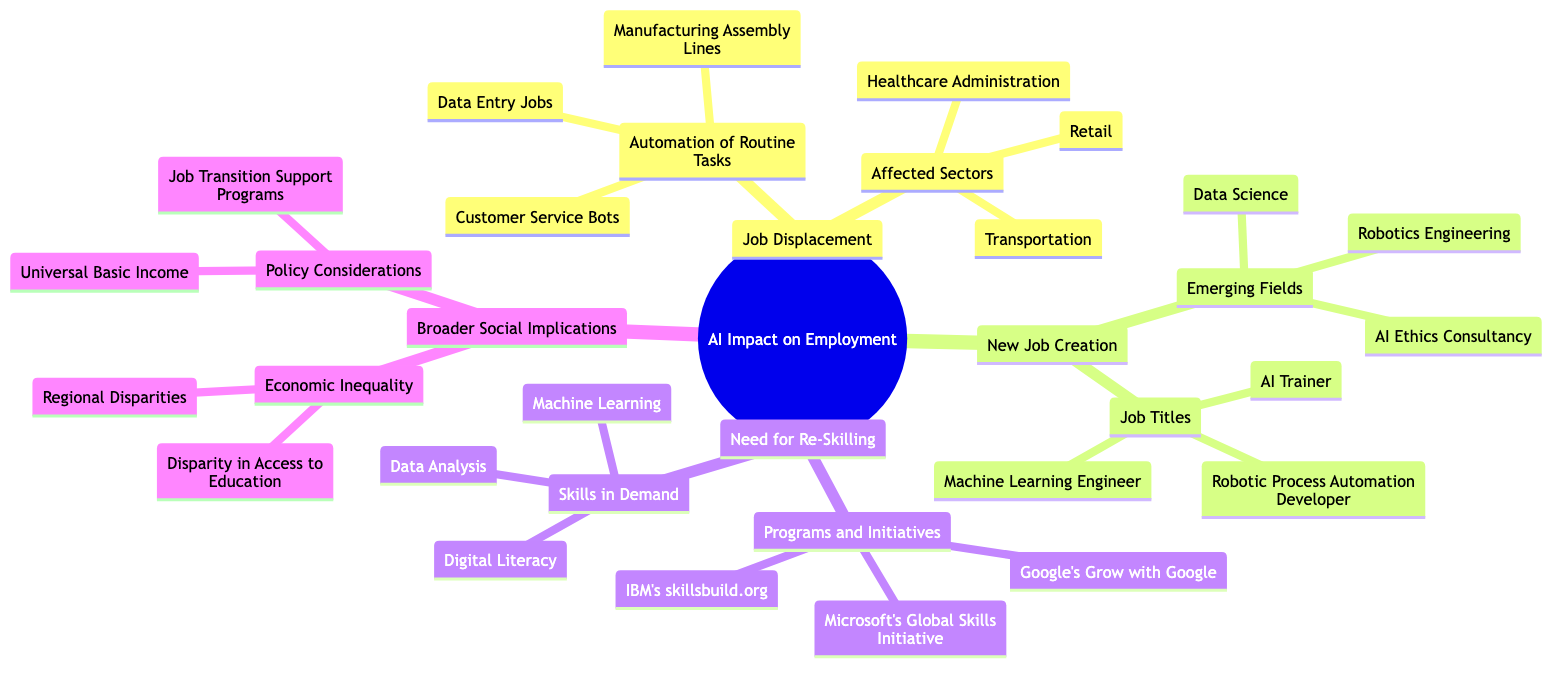What are three examples of routine tasks that could be automated? The diagram lists three specific examples under "Automation of Routine Tasks": Manufacturing Assembly Lines, Data Entry Jobs, and Customer Service Bots. These are key representative tasks that AI may take over.
Answer: Manufacturing Assembly Lines, Data Entry Jobs, Customer Service Bots What sectors are affected by job displacement? The diagram explicitly states three sectors suffering from job displacement: Retail, Transportation, and Healthcare Administration. These sectors are highlighted under the "Affected Sectors" node.
Answer: Retail, Transportation, Healthcare Administration What are two emerging fields where new jobs are being created? Under "Emerging Fields," the diagram mentions three specific fields, but to answer this, we select two: AI Ethics Consultancy and Data Science. These fields indicate areas where there is growing demand for skilled labor due to AI developments.
Answer: AI Ethics Consultancy, Data Science How many job titles are listed under new job creation? The diagram specifies three job titles under the "Job Titles" section related to new job creation, which includes titles like AI Trainer, Machine Learning Engineer, and Robotic Process Automation Developer. Hence, the total is three.
Answer: 3 What is one initiative focused on re-skilling? From the "Programs and Initiatives" category, the diagram lists three programs, among them Google's Grow with Google. This is a clear example of a re-skilling initiative aimed at helping individuals learn new skills for the AI workforce.
Answer: Google's Grow with Google What skills are in demand according to the diagram? The diagram identifies three skills that are particularly in demand: Data Analysis, Machine Learning, and Digital Literacy. These skills are essential for adapting to the changes brought by AI in the job market.
Answer: Data Analysis, Machine Learning, Digital Literacy Which broader social implication is related to education? The diagram mentions "Disparity in Access to Education" under the "Economic Inequality" section as a critical issue. This highlights the connection between AI impacts on employment and social equity, emphasizing educational disparities.
Answer: Disparity in Access to Education What are two policy considerations mentioned in the diagram? Under the "Policy Considerations" category, the diagram elaborates on two specific policies: Universal Basic Income and Job Transition Support Programs. These policies reflect societal responses to the challenges posed by AI on employment.
Answer: Universal Basic Income, Job Transition Support Programs 